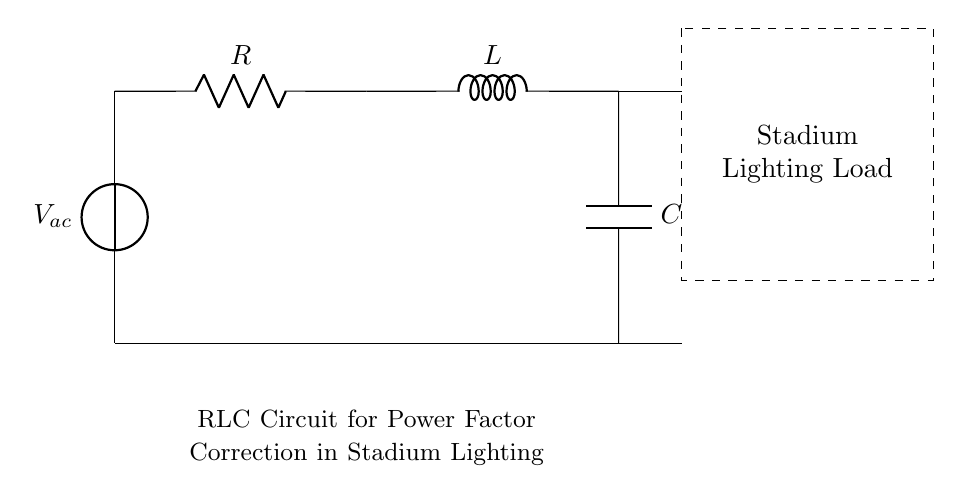What does the circuit primarily represent? The circuit primarily represents an RLC circuit used for power factor correction in stadium lighting systems. This can be inferred from the combination of resistor, inductor, and capacitor in the diagram.
Answer: RLC circuit for power factor correction What components are present in the circuit? The circuit includes a resistor, an inductor, and a capacitor. Each component serves to modulate the electrical characteristics of the stadium lighting system, which is a critical aspect of the circuit's design.
Answer: Resistor, Inductor, Capacitor How is the voltage source labeled in the diagram? The voltage source is labeled as V ac, indicating that it is an alternating current source, which is typically used in stadium lighting systems to ensure efficient operation.
Answer: V ac What effect does the inductor have on the circuit? The inductor introduces inductive reactance, which affects the overall impedance of the circuit and thereby modifies the power factor. This is particularly relevant in optimizing the circuit for effective energy usage in stadium lighting.
Answer: Inductive reactance Why is power factor correction important in this circuit? Power factor correction is crucial in this circuit because it improves the efficiency of power usage, reduces energy losses, and minimizes the risk of overloading the electric supply, which is essential for high-demand applications like stadium lighting.
Answer: To improve efficiency 